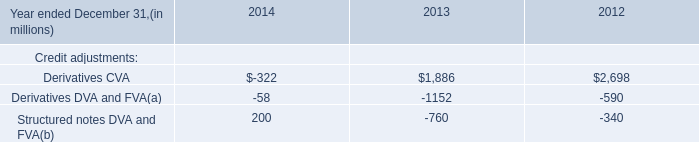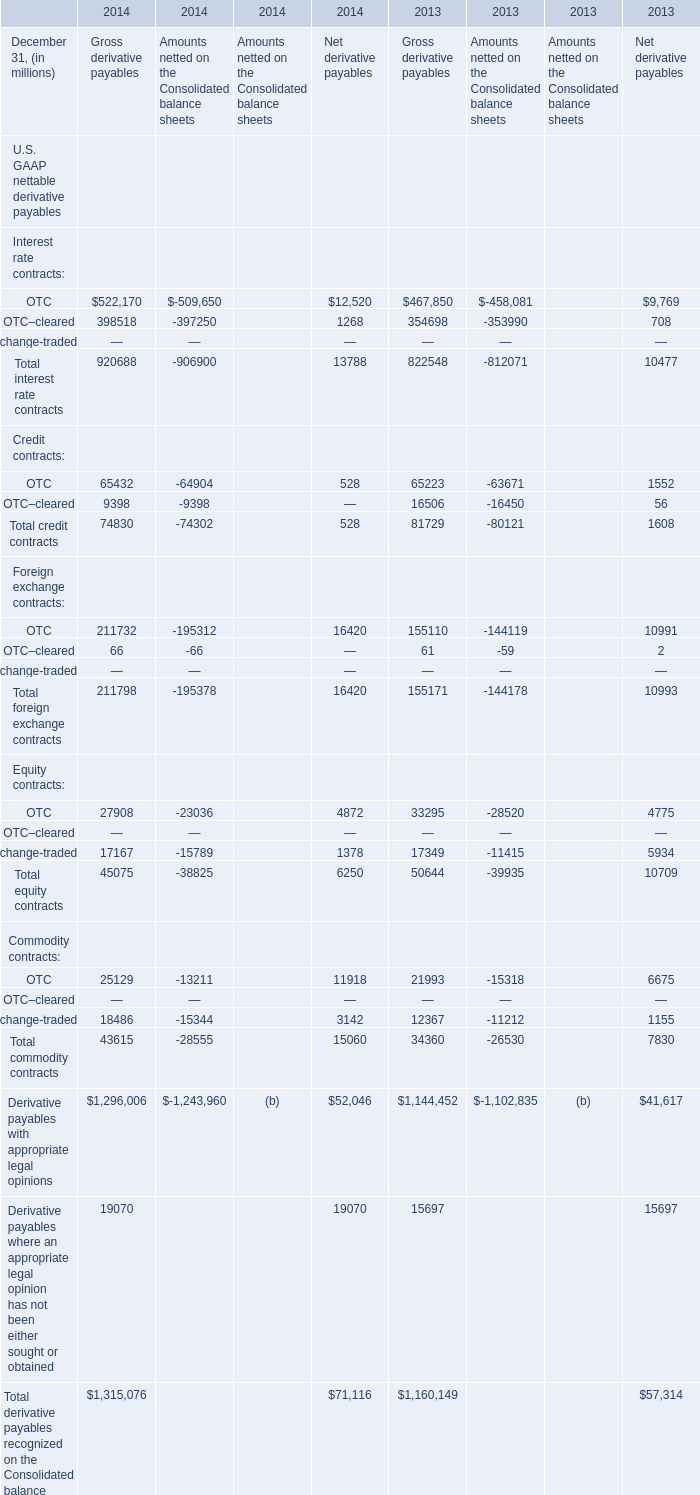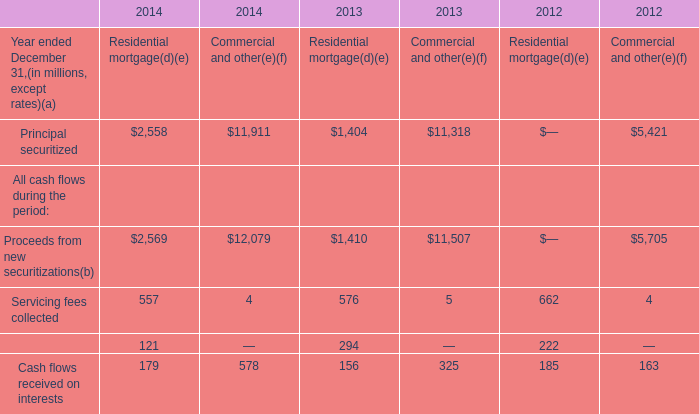Does the value of OTC in 2014 greater than that in 2013 for Gross derivative payables? 
Answer: no. 